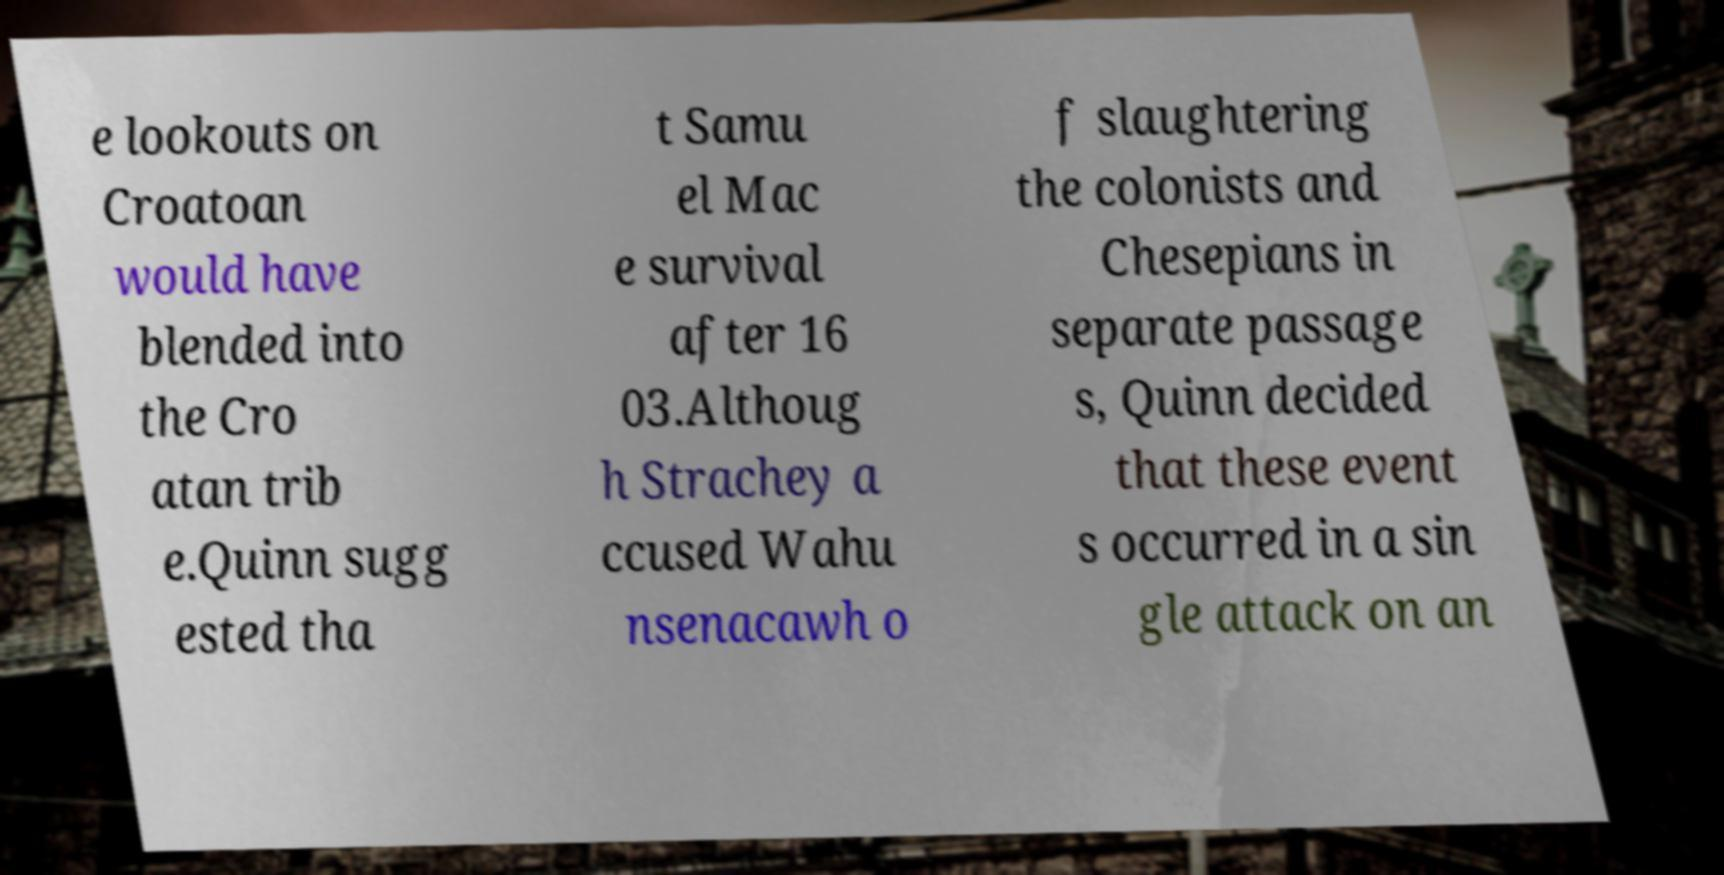Please identify and transcribe the text found in this image. e lookouts on Croatoan would have blended into the Cro atan trib e.Quinn sugg ested tha t Samu el Mac e survival after 16 03.Althoug h Strachey a ccused Wahu nsenacawh o f slaughtering the colonists and Chesepians in separate passage s, Quinn decided that these event s occurred in a sin gle attack on an 